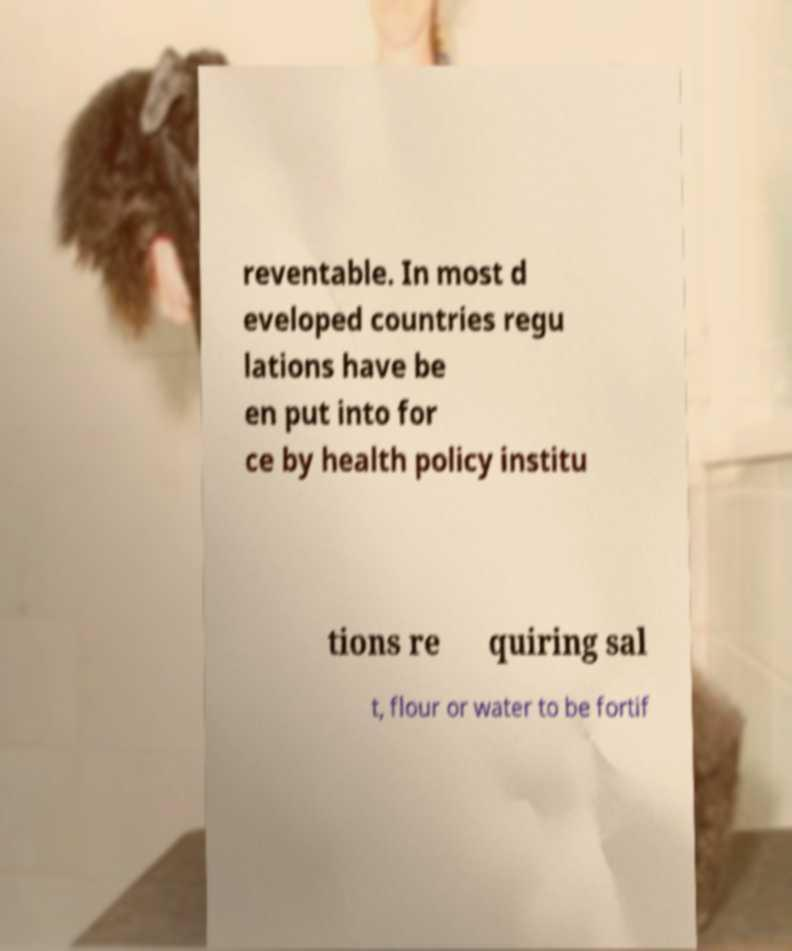I need the written content from this picture converted into text. Can you do that? reventable. In most d eveloped countries regu lations have be en put into for ce by health policy institu tions re quiring sal t, flour or water to be fortif 